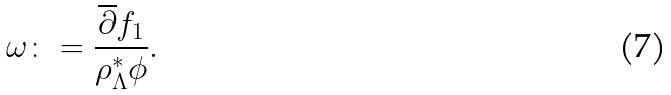<formula> <loc_0><loc_0><loc_500><loc_500>\omega \colon = \frac { \overline { \partial } f _ { 1 } } { \rho _ { \Lambda } ^ { * } \phi } .</formula> 